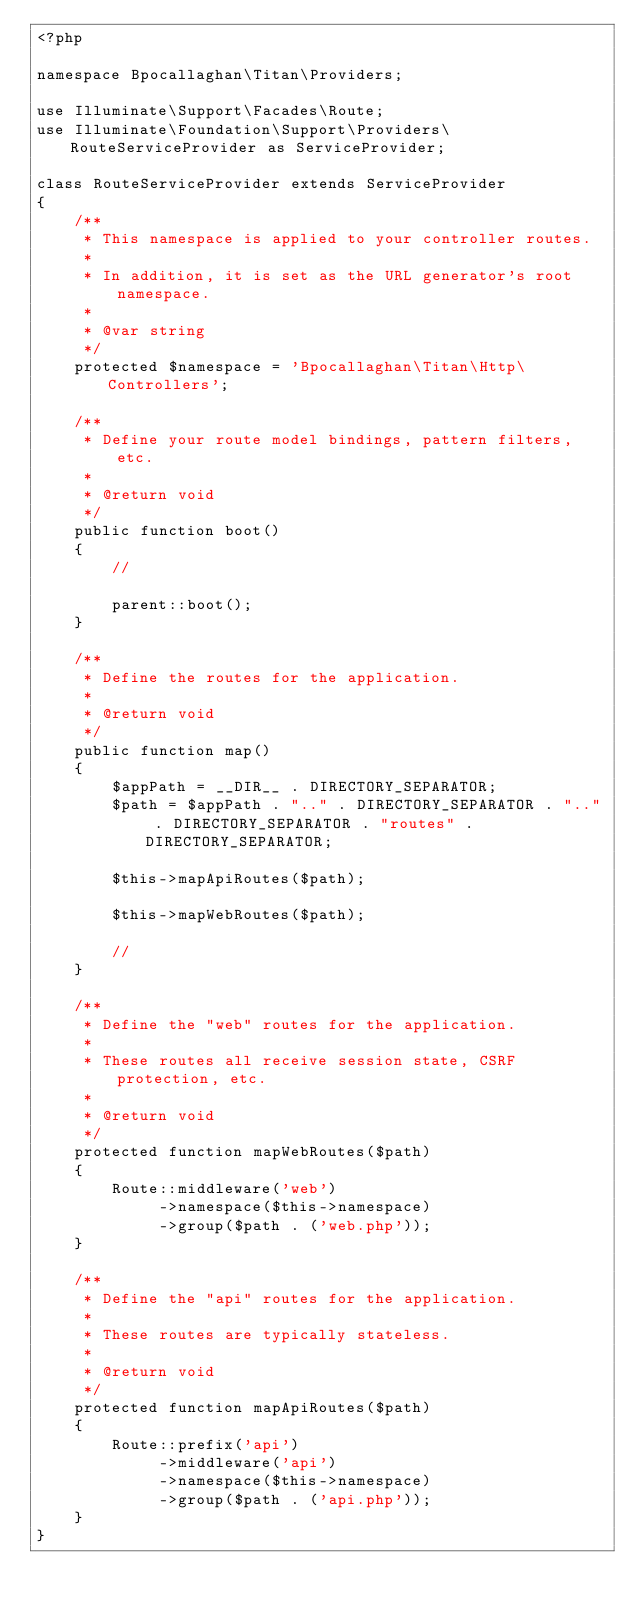<code> <loc_0><loc_0><loc_500><loc_500><_PHP_><?php

namespace Bpocallaghan\Titan\Providers;

use Illuminate\Support\Facades\Route;
use Illuminate\Foundation\Support\Providers\RouteServiceProvider as ServiceProvider;

class RouteServiceProvider extends ServiceProvider
{
    /**
     * This namespace is applied to your controller routes.
     *
     * In addition, it is set as the URL generator's root namespace.
     *
     * @var string
     */
    protected $namespace = 'Bpocallaghan\Titan\Http\Controllers';

    /**
     * Define your route model bindings, pattern filters, etc.
     *
     * @return void
     */
    public function boot()
    {
        //

        parent::boot();
    }

    /**
     * Define the routes for the application.
     *
     * @return void
     */
    public function map()
    {
        $appPath = __DIR__ . DIRECTORY_SEPARATOR;
        $path = $appPath . ".." . DIRECTORY_SEPARATOR . ".." . DIRECTORY_SEPARATOR . "routes" . DIRECTORY_SEPARATOR;

        $this->mapApiRoutes($path);

        $this->mapWebRoutes($path);

        //
    }

    /**
     * Define the "web" routes for the application.
     *
     * These routes all receive session state, CSRF protection, etc.
     *
     * @return void
     */
    protected function mapWebRoutes($path)
    {
        Route::middleware('web')
             ->namespace($this->namespace)
             ->group($path . ('web.php'));
    }

    /**
     * Define the "api" routes for the application.
     *
     * These routes are typically stateless.
     *
     * @return void
     */
    protected function mapApiRoutes($path)
    {
        Route::prefix('api')
             ->middleware('api')
             ->namespace($this->namespace)
             ->group($path . ('api.php'));
    }
}
</code> 